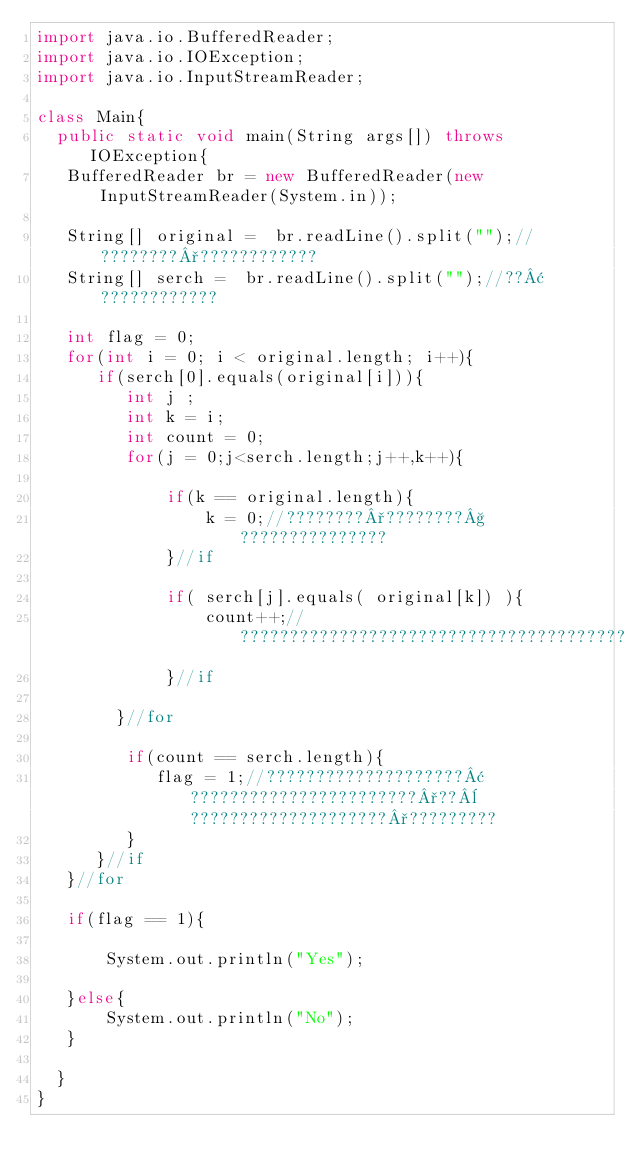<code> <loc_0><loc_0><loc_500><loc_500><_Java_>import java.io.BufferedReader;
import java.io.IOException;
import java.io.InputStreamReader;
 
class Main{
  public static void main(String args[]) throws IOException{
   BufferedReader br = new BufferedReader(new InputStreamReader(System.in));
 
   String[] original =  br.readLine().split("");//????????°????????????
   String[] serch =  br.readLine().split("");//??¢????????????
 
   int flag = 0;
   for(int i = 0; i < original.length; i++){
      if(serch[0].equals(original[i])){
         int j ;
         int k = i;
         int count = 0;
         for(j = 0;j<serch.length;j++,k++){

             if(k == original.length){
                 k = 0;//????????°????????§???????????????
             }//if
  
             if( serch[j].equals( original[k]) ){
                 count++;//???????????????????????????????????????
             }//if
 
        }//for
 
         if(count == serch.length){
            flag = 1;//????????????????????¢???????????????????????°??¨????????????????????°?????????
         }
      }//if
   }//for
 
   if(flag == 1){
 
       System.out.println("Yes");
 
   }else{
       System.out.println("No");
   }
 
  }
}</code> 